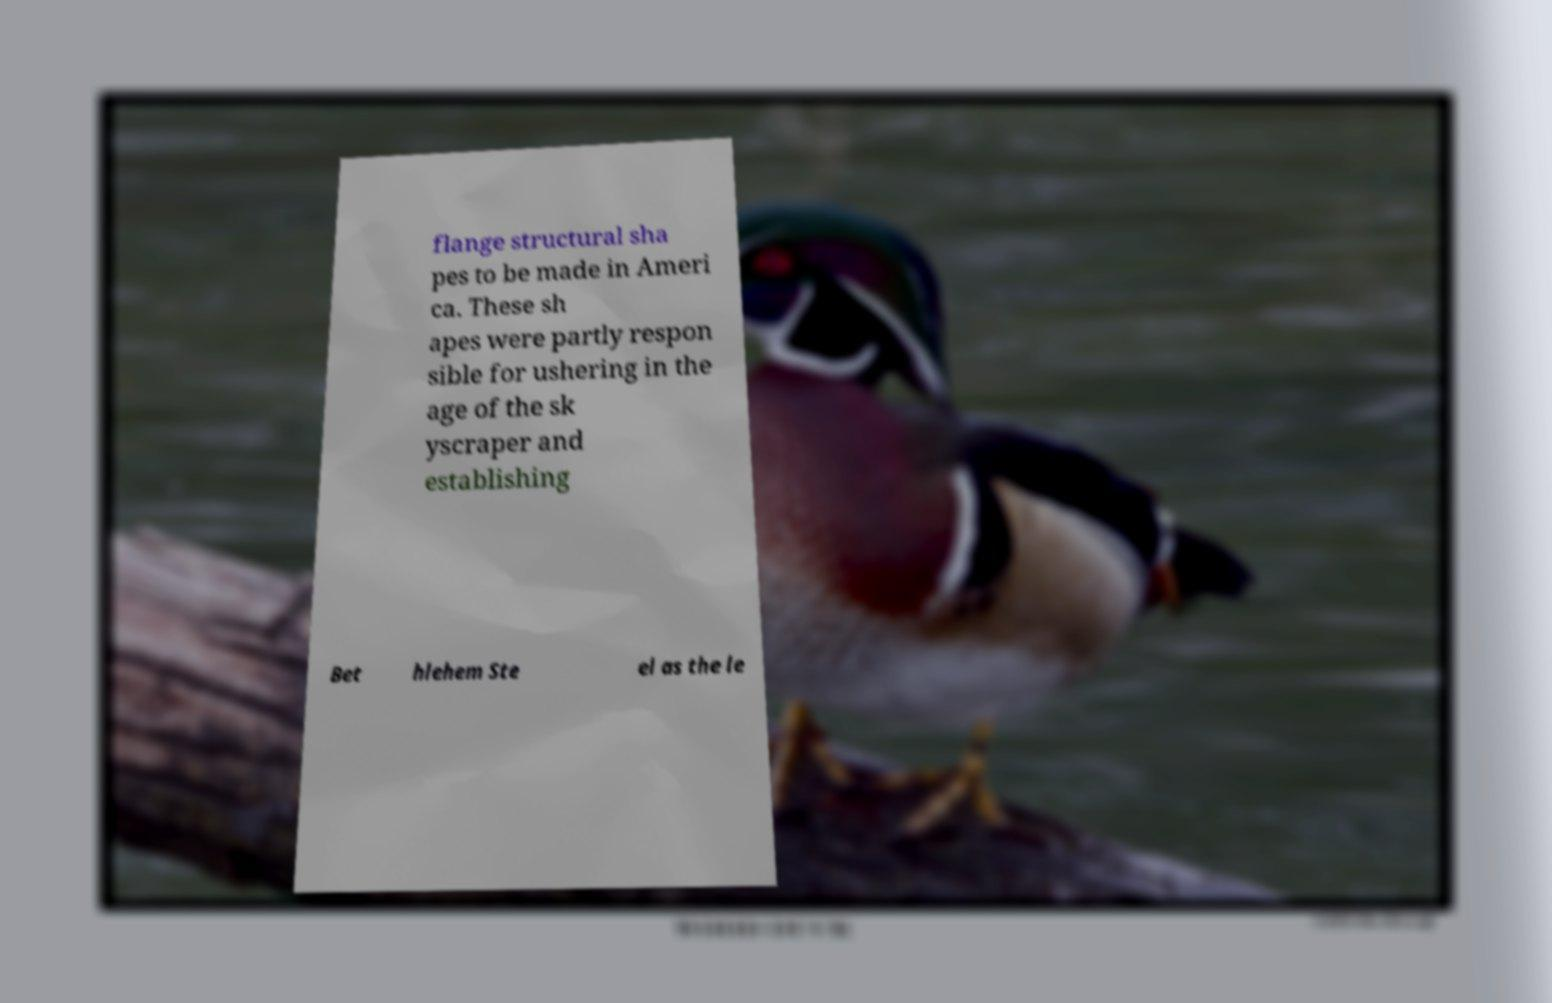Please read and relay the text visible in this image. What does it say? flange structural sha pes to be made in Ameri ca. These sh apes were partly respon sible for ushering in the age of the sk yscraper and establishing Bet hlehem Ste el as the le 